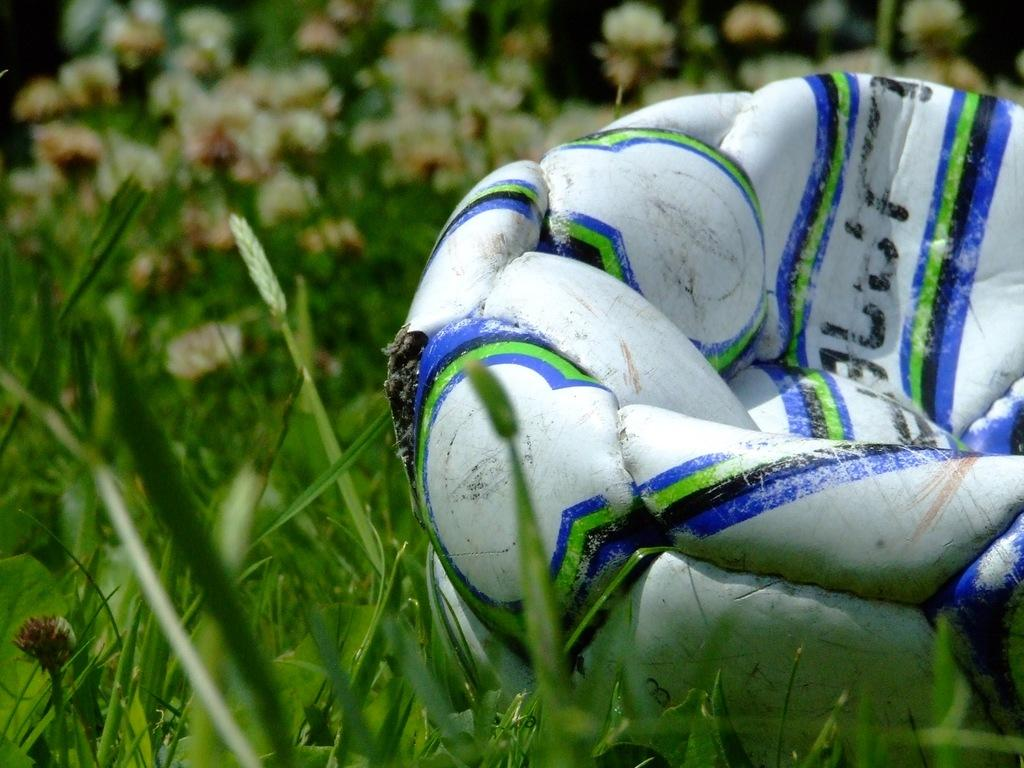What object is located on the right side of the image? There is a football on the right side of the image. What type of surface is visible in the background of the image? There is grass in the background of the image. What other natural elements can be seen in the background of the image? There are plants in the background of the image. What relation does the grandmother have to the football in the image? There is no grandmother present in the image, and therefore no relation can be established. 